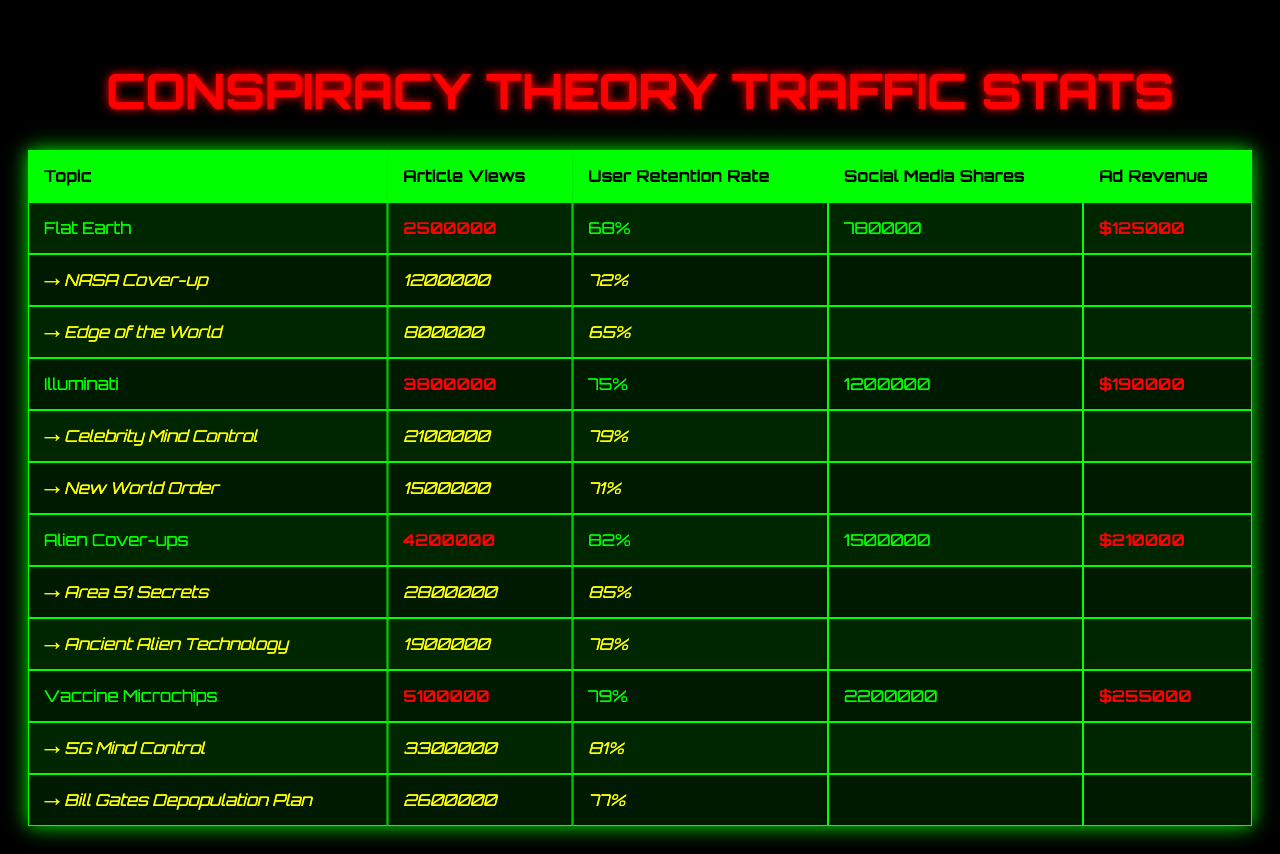What is the total number of article views for the "Vaccine Microchips" topic? The table shows that the "Vaccine Microchips" topic has 5,100,000 article views.
Answer: 5,100,000 Which topic has the highest user retention rate? The highest user retention rate in the table is 82% for the "Alien Cover-ups" topic.
Answer: Alien Cover-ups How many subtopics are listed under "Illuminati"? Under the "Illuminati" topic, there are 2 subtopics listed: "Celebrity Mind Control" and "New World Order."
Answer: 2 What is the total ad revenue for all topics combined? The ad revenue for each topic is: Flat Earth ($125,000), Illuminati ($190,000), Alien Cover-ups ($210,000), Vaccine Microchips ($255,000). Summing these gives: $125,000 + $190,000 + $210,000 + $255,000 = $780,000.
Answer: $780,000 Are there more social media shares for the "Alien Cover-ups" topic than for "Flat Earth"? The "Alien Cover-ups" topic has 1,500,000 social media shares, while the "Flat Earth" topic has 780,000 shares, which means "Alien Cover-ups" has more shares.
Answer: Yes What is the average user retention rate of all four main topics? The user retention rates are: 68% for Flat Earth, 75% for Illuminati, 82% for Alien Cover-ups, and 79% for Vaccine Microchips. The average is (68 + 75 + 82 + 79) / 4 = 76%.
Answer: 76% Which subtopic under "Vaccine Microchips" has a retention rate below 80%? The subtopic "Bill Gates Depopulation Plan" has a retention rate of 77%, which is below 80%.
Answer: Bill Gates Depopulation Plan How many more views does the "Alien Cover-ups" topic have compared to the "Illuminati" topic? The "Alien Cover-ups" topic has 4,200,000 views, while the "Illuminati" topic has 3,800,000 views. The difference is 4,200,000 - 3,800,000 = 400,000 views.
Answer: 400,000 Which topic earns the highest ad revenue? The "Vaccine Microchips" topic generates the highest ad revenue at $255,000, compared to the others.
Answer: Vaccine Microchips Is the user retention rate for "Edge of the World" higher than that for "Area 51 Secrets"? The user retention rate for "Edge of the World" is 65%, and for "Area 51 Secrets" it is 85%. Since 65% is less than 85%, it is not higher.
Answer: No What is the total article view count for all subtopics under "Flat Earth"? The subtopics under "Flat Earth" are "NASA Cover-up" (1,200,000 views) and "Edge of the World" (800,000 views). Summing these gives 1,200,000 + 800,000 = 2,000,000 views.
Answer: 2,000,000 